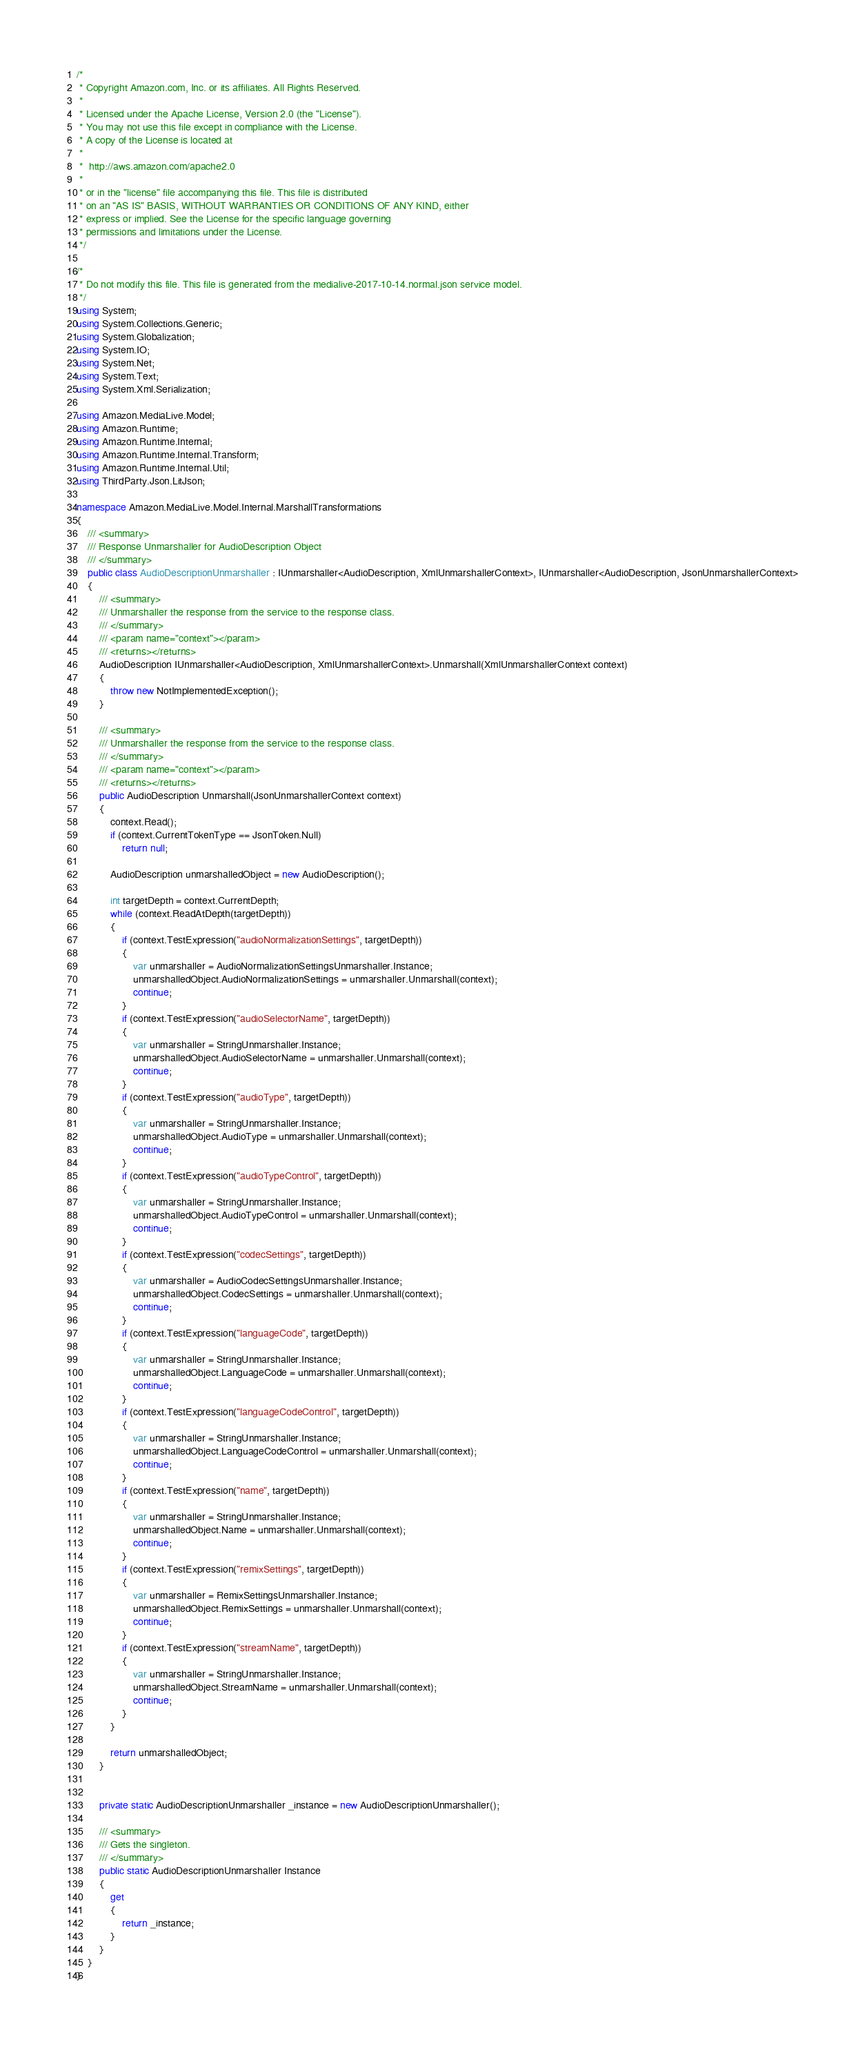Convert code to text. <code><loc_0><loc_0><loc_500><loc_500><_C#_>/*
 * Copyright Amazon.com, Inc. or its affiliates. All Rights Reserved.
 * 
 * Licensed under the Apache License, Version 2.0 (the "License").
 * You may not use this file except in compliance with the License.
 * A copy of the License is located at
 * 
 *  http://aws.amazon.com/apache2.0
 * 
 * or in the "license" file accompanying this file. This file is distributed
 * on an "AS IS" BASIS, WITHOUT WARRANTIES OR CONDITIONS OF ANY KIND, either
 * express or implied. See the License for the specific language governing
 * permissions and limitations under the License.
 */

/*
 * Do not modify this file. This file is generated from the medialive-2017-10-14.normal.json service model.
 */
using System;
using System.Collections.Generic;
using System.Globalization;
using System.IO;
using System.Net;
using System.Text;
using System.Xml.Serialization;

using Amazon.MediaLive.Model;
using Amazon.Runtime;
using Amazon.Runtime.Internal;
using Amazon.Runtime.Internal.Transform;
using Amazon.Runtime.Internal.Util;
using ThirdParty.Json.LitJson;

namespace Amazon.MediaLive.Model.Internal.MarshallTransformations
{
    /// <summary>
    /// Response Unmarshaller for AudioDescription Object
    /// </summary>  
    public class AudioDescriptionUnmarshaller : IUnmarshaller<AudioDescription, XmlUnmarshallerContext>, IUnmarshaller<AudioDescription, JsonUnmarshallerContext>
    {
        /// <summary>
        /// Unmarshaller the response from the service to the response class.
        /// </summary>  
        /// <param name="context"></param>
        /// <returns></returns>
        AudioDescription IUnmarshaller<AudioDescription, XmlUnmarshallerContext>.Unmarshall(XmlUnmarshallerContext context)
        {
            throw new NotImplementedException();
        }

        /// <summary>
        /// Unmarshaller the response from the service to the response class.
        /// </summary>  
        /// <param name="context"></param>
        /// <returns></returns>
        public AudioDescription Unmarshall(JsonUnmarshallerContext context)
        {
            context.Read();
            if (context.CurrentTokenType == JsonToken.Null) 
                return null;

            AudioDescription unmarshalledObject = new AudioDescription();
        
            int targetDepth = context.CurrentDepth;
            while (context.ReadAtDepth(targetDepth))
            {
                if (context.TestExpression("audioNormalizationSettings", targetDepth))
                {
                    var unmarshaller = AudioNormalizationSettingsUnmarshaller.Instance;
                    unmarshalledObject.AudioNormalizationSettings = unmarshaller.Unmarshall(context);
                    continue;
                }
                if (context.TestExpression("audioSelectorName", targetDepth))
                {
                    var unmarshaller = StringUnmarshaller.Instance;
                    unmarshalledObject.AudioSelectorName = unmarshaller.Unmarshall(context);
                    continue;
                }
                if (context.TestExpression("audioType", targetDepth))
                {
                    var unmarshaller = StringUnmarshaller.Instance;
                    unmarshalledObject.AudioType = unmarshaller.Unmarshall(context);
                    continue;
                }
                if (context.TestExpression("audioTypeControl", targetDepth))
                {
                    var unmarshaller = StringUnmarshaller.Instance;
                    unmarshalledObject.AudioTypeControl = unmarshaller.Unmarshall(context);
                    continue;
                }
                if (context.TestExpression("codecSettings", targetDepth))
                {
                    var unmarshaller = AudioCodecSettingsUnmarshaller.Instance;
                    unmarshalledObject.CodecSettings = unmarshaller.Unmarshall(context);
                    continue;
                }
                if (context.TestExpression("languageCode", targetDepth))
                {
                    var unmarshaller = StringUnmarshaller.Instance;
                    unmarshalledObject.LanguageCode = unmarshaller.Unmarshall(context);
                    continue;
                }
                if (context.TestExpression("languageCodeControl", targetDepth))
                {
                    var unmarshaller = StringUnmarshaller.Instance;
                    unmarshalledObject.LanguageCodeControl = unmarshaller.Unmarshall(context);
                    continue;
                }
                if (context.TestExpression("name", targetDepth))
                {
                    var unmarshaller = StringUnmarshaller.Instance;
                    unmarshalledObject.Name = unmarshaller.Unmarshall(context);
                    continue;
                }
                if (context.TestExpression("remixSettings", targetDepth))
                {
                    var unmarshaller = RemixSettingsUnmarshaller.Instance;
                    unmarshalledObject.RemixSettings = unmarshaller.Unmarshall(context);
                    continue;
                }
                if (context.TestExpression("streamName", targetDepth))
                {
                    var unmarshaller = StringUnmarshaller.Instance;
                    unmarshalledObject.StreamName = unmarshaller.Unmarshall(context);
                    continue;
                }
            }
          
            return unmarshalledObject;
        }


        private static AudioDescriptionUnmarshaller _instance = new AudioDescriptionUnmarshaller();        

        /// <summary>
        /// Gets the singleton.
        /// </summary>  
        public static AudioDescriptionUnmarshaller Instance
        {
            get
            {
                return _instance;
            }
        }
    }
}</code> 